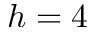Convert formula to latex. <formula><loc_0><loc_0><loc_500><loc_500>h = 4</formula> 